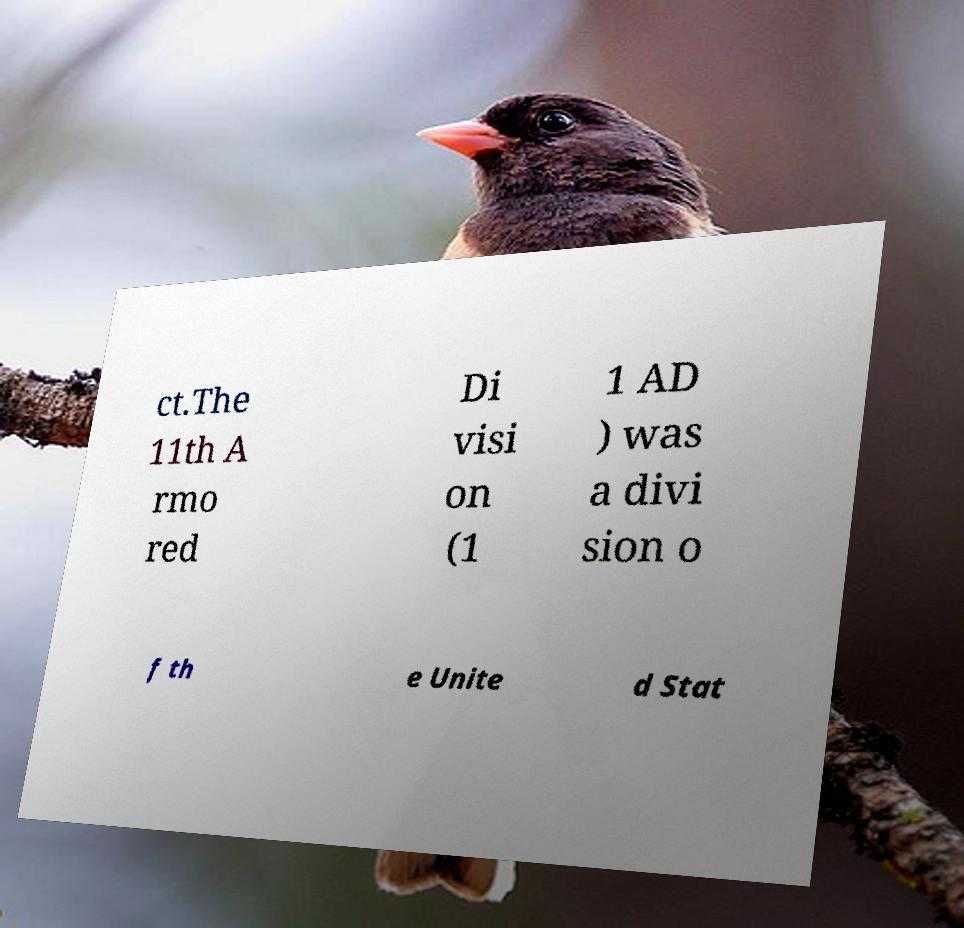I need the written content from this picture converted into text. Can you do that? ct.The 11th A rmo red Di visi on (1 1 AD ) was a divi sion o f th e Unite d Stat 